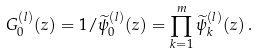<formula> <loc_0><loc_0><loc_500><loc_500>G _ { 0 } ^ { ( l ) } ( z ) = 1 / \widetilde { \psi } _ { 0 } ^ { ( l ) } ( z ) = \prod _ { k = 1 } ^ { m } \widetilde { \psi } ^ { ( l ) } _ { k } ( z ) \, .</formula> 